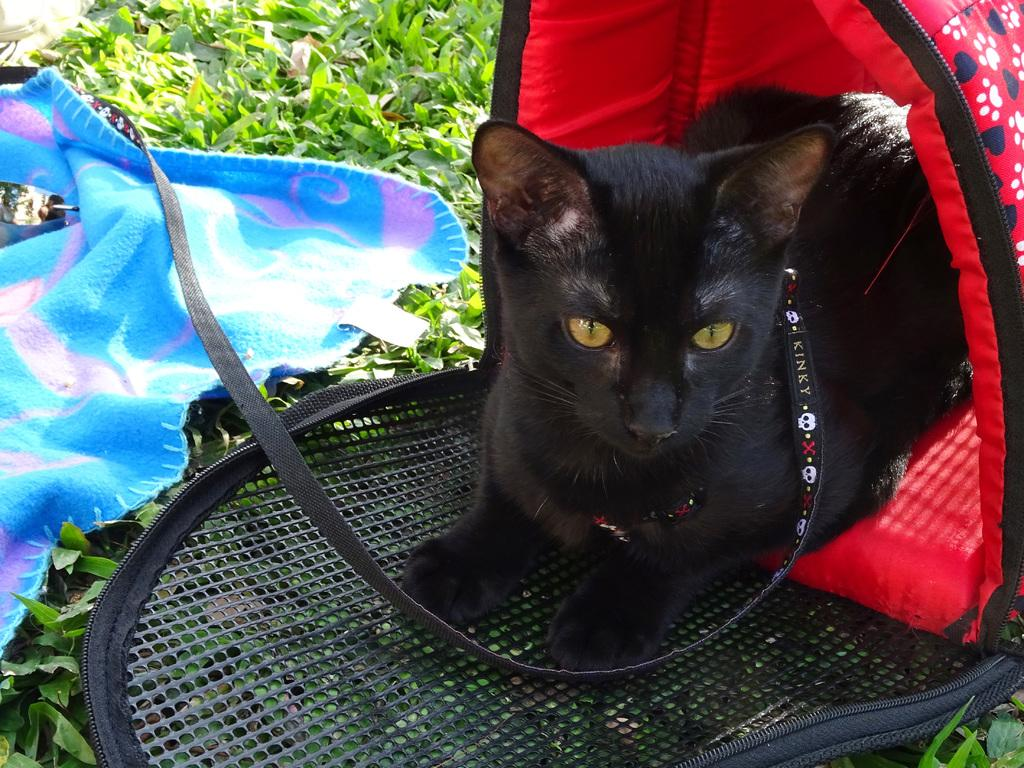What animal can be seen in the image? There is a cat in the image. Where is the cat located in the image? The cat is sitting in a cat tent. What is covering the grass in the image? There is a cloth on the grass in the image. Is there a volcano erupting in the background of the image? No, there is no volcano or any indication of an eruption in the image. What type of watch is the cat wearing on its paw? There is no watch present on the cat's paw in the image. 